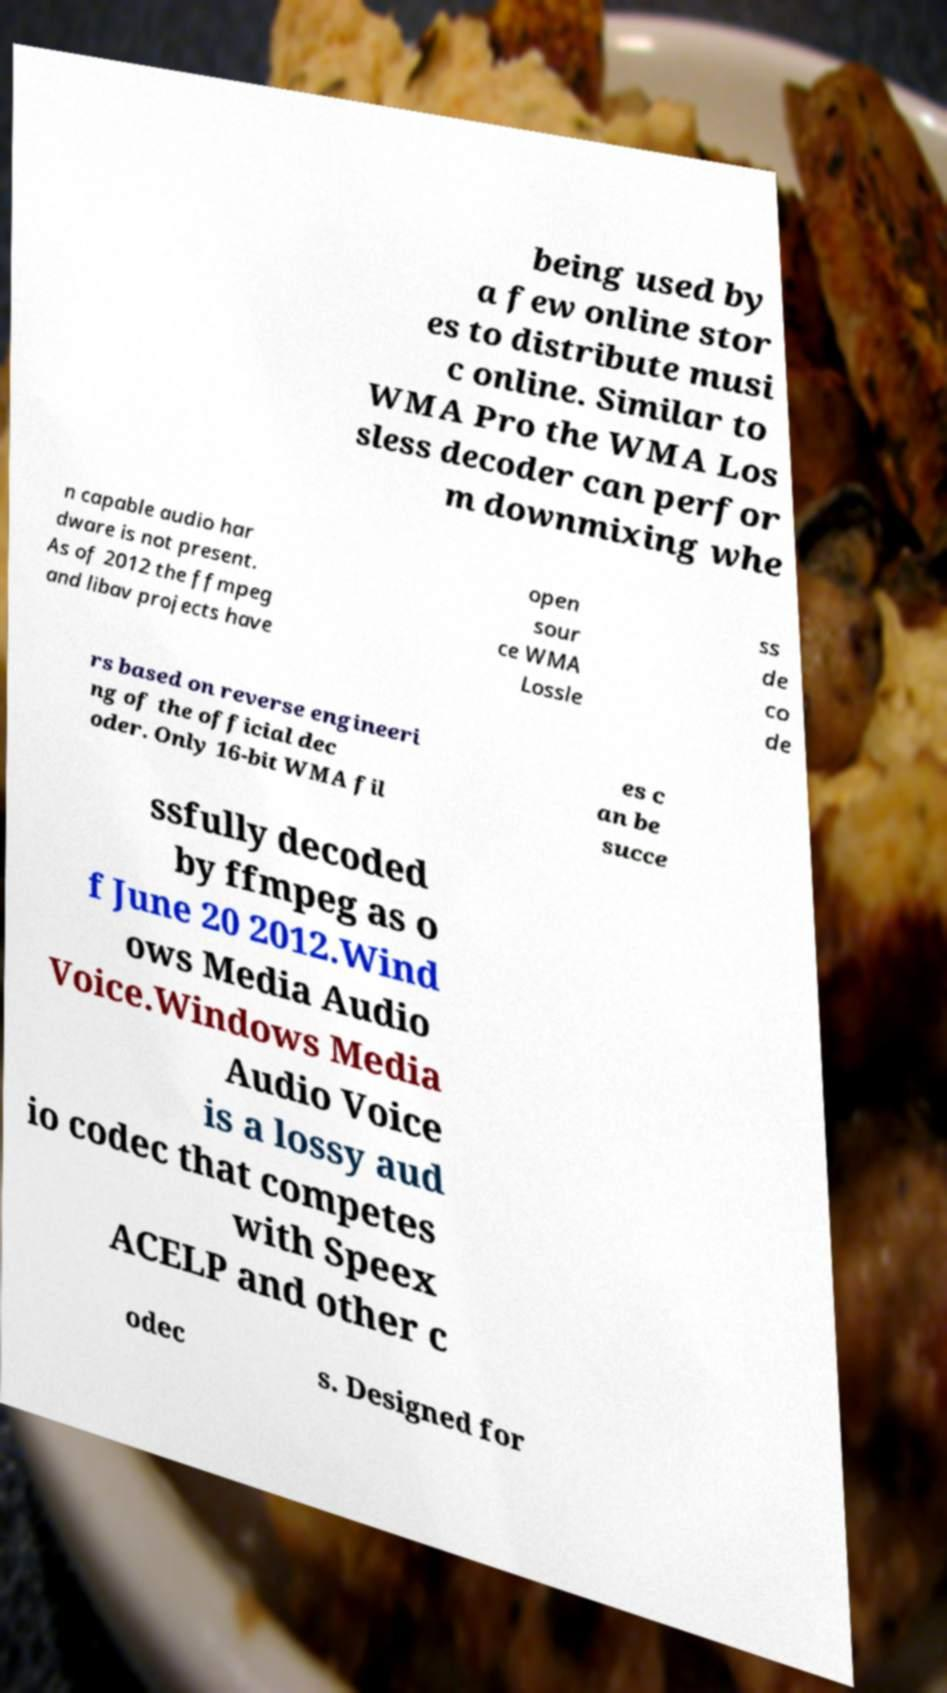There's text embedded in this image that I need extracted. Can you transcribe it verbatim? being used by a few online stor es to distribute musi c online. Similar to WMA Pro the WMA Los sless decoder can perfor m downmixing whe n capable audio har dware is not present. As of 2012 the ffmpeg and libav projects have open sour ce WMA Lossle ss de co de rs based on reverse engineeri ng of the official dec oder. Only 16-bit WMA fil es c an be succe ssfully decoded by ffmpeg as o f June 20 2012.Wind ows Media Audio Voice.Windows Media Audio Voice is a lossy aud io codec that competes with Speex ACELP and other c odec s. Designed for 